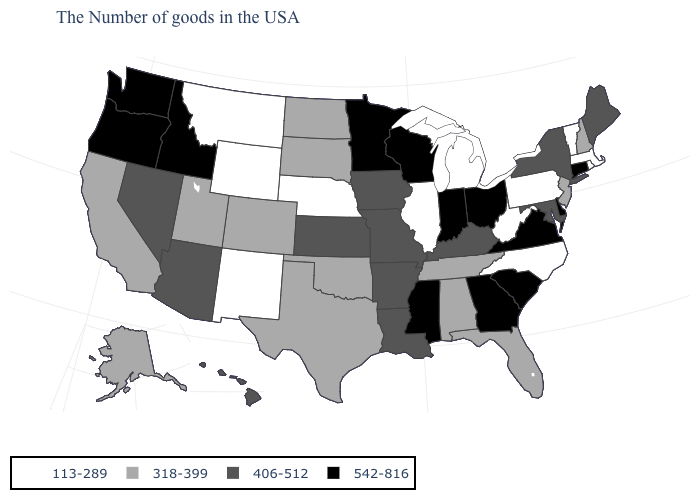Among the states that border South Carolina , which have the lowest value?
Keep it brief. North Carolina. What is the value of Nevada?
Concise answer only. 406-512. What is the value of New Jersey?
Be succinct. 318-399. Does the first symbol in the legend represent the smallest category?
Write a very short answer. Yes. How many symbols are there in the legend?
Write a very short answer. 4. Does Arkansas have the same value as New Mexico?
Give a very brief answer. No. Does Montana have a lower value than Nebraska?
Keep it brief. No. Does the first symbol in the legend represent the smallest category?
Be succinct. Yes. What is the value of Connecticut?
Give a very brief answer. 542-816. Name the states that have a value in the range 406-512?
Be succinct. Maine, New York, Maryland, Kentucky, Louisiana, Missouri, Arkansas, Iowa, Kansas, Arizona, Nevada, Hawaii. Name the states that have a value in the range 113-289?
Concise answer only. Massachusetts, Rhode Island, Vermont, Pennsylvania, North Carolina, West Virginia, Michigan, Illinois, Nebraska, Wyoming, New Mexico, Montana. What is the value of South Dakota?
Short answer required. 318-399. Name the states that have a value in the range 406-512?
Give a very brief answer. Maine, New York, Maryland, Kentucky, Louisiana, Missouri, Arkansas, Iowa, Kansas, Arizona, Nevada, Hawaii. Among the states that border South Carolina , does North Carolina have the lowest value?
Quick response, please. Yes. Does Montana have the lowest value in the West?
Answer briefly. Yes. 